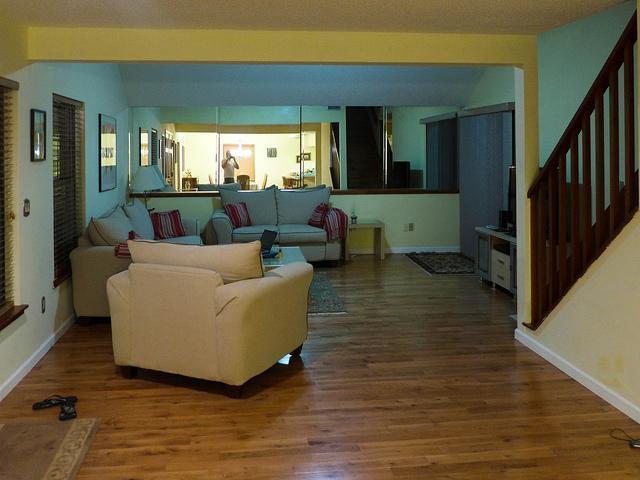How many couches are there?
Give a very brief answer. 2. How many zebras are on the road?
Give a very brief answer. 0. 